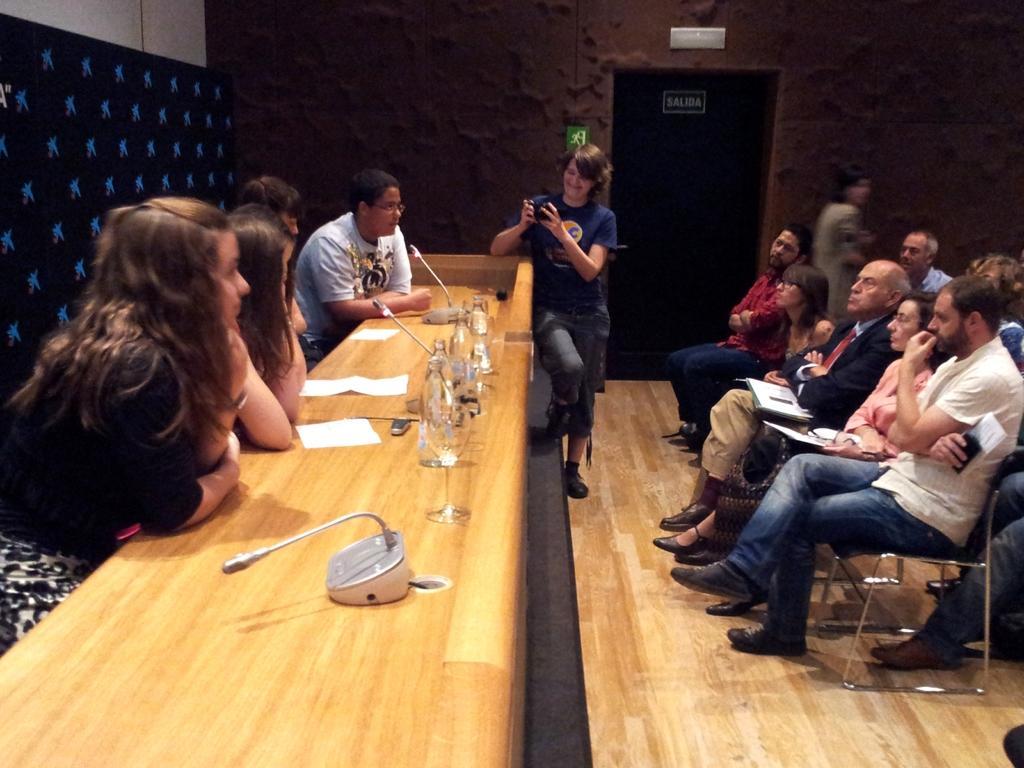How would you summarize this image in a sentence or two? In this image there are chairs and tables. On the table there are water bottles and mike. There is a wall on the left side. There is a brown color wall in the background. There is a door in the background which is closed. There are people. 